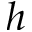<formula> <loc_0><loc_0><loc_500><loc_500>h</formula> 